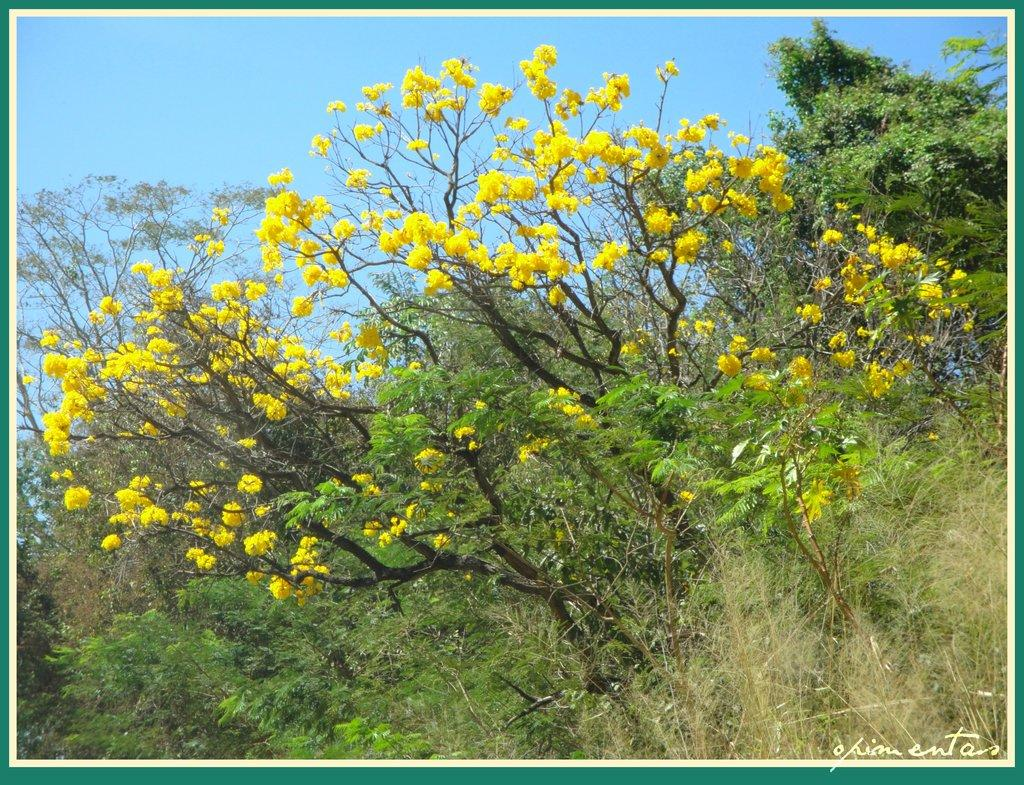What type of tree is in the image? There is a flower tree in the image. What color are the flowers on the tree? The flowers on the tree are yellow. Where is the tree located in the image? The tree is in the front of the image. What can be seen at the front bottom side of the image? There is grass and plants in the front bottom side of the image. What is the error code displayed on the tree in the image? There is no error code displayed on the tree in the image, as it is a flower tree and not a machine or device. 